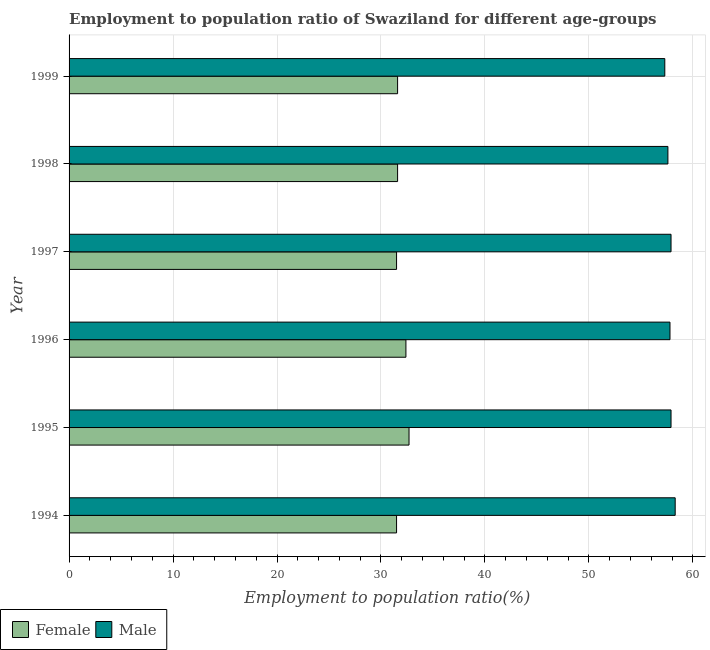How many different coloured bars are there?
Your answer should be very brief. 2. How many groups of bars are there?
Offer a very short reply. 6. How many bars are there on the 3rd tick from the bottom?
Ensure brevity in your answer.  2. What is the label of the 5th group of bars from the top?
Provide a succinct answer. 1995. In how many cases, is the number of bars for a given year not equal to the number of legend labels?
Provide a short and direct response. 0. What is the employment to population ratio(male) in 1994?
Your answer should be compact. 58.3. Across all years, what is the maximum employment to population ratio(male)?
Make the answer very short. 58.3. Across all years, what is the minimum employment to population ratio(female)?
Ensure brevity in your answer.  31.5. In which year was the employment to population ratio(male) maximum?
Offer a terse response. 1994. What is the total employment to population ratio(male) in the graph?
Offer a very short reply. 346.8. What is the difference between the employment to population ratio(male) in 1995 and the employment to population ratio(female) in 1999?
Offer a terse response. 26.3. What is the average employment to population ratio(female) per year?
Ensure brevity in your answer.  31.88. In the year 1997, what is the difference between the employment to population ratio(male) and employment to population ratio(female)?
Give a very brief answer. 26.4. What is the ratio of the employment to population ratio(male) in 1995 to that in 1997?
Keep it short and to the point. 1. What is the difference between the highest and the second highest employment to population ratio(male)?
Ensure brevity in your answer.  0.4. In how many years, is the employment to population ratio(female) greater than the average employment to population ratio(female) taken over all years?
Your answer should be very brief. 2. Is the sum of the employment to population ratio(female) in 1995 and 1996 greater than the maximum employment to population ratio(male) across all years?
Ensure brevity in your answer.  Yes. What does the 2nd bar from the top in 1996 represents?
Your response must be concise. Female. How many bars are there?
Provide a succinct answer. 12. How many years are there in the graph?
Make the answer very short. 6. Does the graph contain any zero values?
Provide a short and direct response. No. Does the graph contain grids?
Offer a terse response. Yes. Where does the legend appear in the graph?
Provide a succinct answer. Bottom left. What is the title of the graph?
Offer a very short reply. Employment to population ratio of Swaziland for different age-groups. Does "Male" appear as one of the legend labels in the graph?
Your answer should be compact. Yes. What is the label or title of the Y-axis?
Your answer should be compact. Year. What is the Employment to population ratio(%) of Female in 1994?
Offer a very short reply. 31.5. What is the Employment to population ratio(%) of Male in 1994?
Your response must be concise. 58.3. What is the Employment to population ratio(%) in Female in 1995?
Ensure brevity in your answer.  32.7. What is the Employment to population ratio(%) in Male in 1995?
Make the answer very short. 57.9. What is the Employment to population ratio(%) in Female in 1996?
Your answer should be compact. 32.4. What is the Employment to population ratio(%) of Male in 1996?
Provide a short and direct response. 57.8. What is the Employment to population ratio(%) of Female in 1997?
Give a very brief answer. 31.5. What is the Employment to population ratio(%) of Male in 1997?
Your answer should be compact. 57.9. What is the Employment to population ratio(%) of Female in 1998?
Provide a short and direct response. 31.6. What is the Employment to population ratio(%) in Male in 1998?
Provide a succinct answer. 57.6. What is the Employment to population ratio(%) in Female in 1999?
Provide a short and direct response. 31.6. What is the Employment to population ratio(%) in Male in 1999?
Your answer should be compact. 57.3. Across all years, what is the maximum Employment to population ratio(%) of Female?
Your response must be concise. 32.7. Across all years, what is the maximum Employment to population ratio(%) in Male?
Your answer should be compact. 58.3. Across all years, what is the minimum Employment to population ratio(%) of Female?
Offer a terse response. 31.5. Across all years, what is the minimum Employment to population ratio(%) in Male?
Offer a very short reply. 57.3. What is the total Employment to population ratio(%) of Female in the graph?
Ensure brevity in your answer.  191.3. What is the total Employment to population ratio(%) of Male in the graph?
Provide a short and direct response. 346.8. What is the difference between the Employment to population ratio(%) in Male in 1994 and that in 1995?
Provide a short and direct response. 0.4. What is the difference between the Employment to population ratio(%) of Female in 1994 and that in 1997?
Make the answer very short. 0. What is the difference between the Employment to population ratio(%) in Male in 1994 and that in 1997?
Your answer should be very brief. 0.4. What is the difference between the Employment to population ratio(%) in Female in 1994 and that in 1998?
Provide a short and direct response. -0.1. What is the difference between the Employment to population ratio(%) in Male in 1994 and that in 1998?
Provide a succinct answer. 0.7. What is the difference between the Employment to population ratio(%) in Male in 1994 and that in 1999?
Ensure brevity in your answer.  1. What is the difference between the Employment to population ratio(%) of Female in 1995 and that in 1996?
Give a very brief answer. 0.3. What is the difference between the Employment to population ratio(%) in Female in 1995 and that in 1998?
Provide a succinct answer. 1.1. What is the difference between the Employment to population ratio(%) in Female in 1995 and that in 1999?
Offer a very short reply. 1.1. What is the difference between the Employment to population ratio(%) in Male in 1995 and that in 1999?
Keep it short and to the point. 0.6. What is the difference between the Employment to population ratio(%) in Female in 1996 and that in 1998?
Keep it short and to the point. 0.8. What is the difference between the Employment to population ratio(%) in Female in 1997 and that in 1998?
Offer a very short reply. -0.1. What is the difference between the Employment to population ratio(%) in Male in 1997 and that in 1998?
Make the answer very short. 0.3. What is the difference between the Employment to population ratio(%) in Female in 1997 and that in 1999?
Ensure brevity in your answer.  -0.1. What is the difference between the Employment to population ratio(%) of Male in 1998 and that in 1999?
Give a very brief answer. 0.3. What is the difference between the Employment to population ratio(%) of Female in 1994 and the Employment to population ratio(%) of Male in 1995?
Keep it short and to the point. -26.4. What is the difference between the Employment to population ratio(%) in Female in 1994 and the Employment to population ratio(%) in Male in 1996?
Offer a very short reply. -26.3. What is the difference between the Employment to population ratio(%) of Female in 1994 and the Employment to population ratio(%) of Male in 1997?
Keep it short and to the point. -26.4. What is the difference between the Employment to population ratio(%) of Female in 1994 and the Employment to population ratio(%) of Male in 1998?
Provide a short and direct response. -26.1. What is the difference between the Employment to population ratio(%) in Female in 1994 and the Employment to population ratio(%) in Male in 1999?
Your answer should be very brief. -25.8. What is the difference between the Employment to population ratio(%) in Female in 1995 and the Employment to population ratio(%) in Male in 1996?
Offer a very short reply. -25.1. What is the difference between the Employment to population ratio(%) in Female in 1995 and the Employment to population ratio(%) in Male in 1997?
Provide a succinct answer. -25.2. What is the difference between the Employment to population ratio(%) in Female in 1995 and the Employment to population ratio(%) in Male in 1998?
Give a very brief answer. -24.9. What is the difference between the Employment to population ratio(%) of Female in 1995 and the Employment to population ratio(%) of Male in 1999?
Make the answer very short. -24.6. What is the difference between the Employment to population ratio(%) of Female in 1996 and the Employment to population ratio(%) of Male in 1997?
Your response must be concise. -25.5. What is the difference between the Employment to population ratio(%) in Female in 1996 and the Employment to population ratio(%) in Male in 1998?
Your answer should be compact. -25.2. What is the difference between the Employment to population ratio(%) of Female in 1996 and the Employment to population ratio(%) of Male in 1999?
Make the answer very short. -24.9. What is the difference between the Employment to population ratio(%) of Female in 1997 and the Employment to population ratio(%) of Male in 1998?
Offer a very short reply. -26.1. What is the difference between the Employment to population ratio(%) of Female in 1997 and the Employment to population ratio(%) of Male in 1999?
Provide a short and direct response. -25.8. What is the difference between the Employment to population ratio(%) of Female in 1998 and the Employment to population ratio(%) of Male in 1999?
Your answer should be compact. -25.7. What is the average Employment to population ratio(%) of Female per year?
Offer a very short reply. 31.88. What is the average Employment to population ratio(%) in Male per year?
Give a very brief answer. 57.8. In the year 1994, what is the difference between the Employment to population ratio(%) in Female and Employment to population ratio(%) in Male?
Offer a very short reply. -26.8. In the year 1995, what is the difference between the Employment to population ratio(%) of Female and Employment to population ratio(%) of Male?
Offer a very short reply. -25.2. In the year 1996, what is the difference between the Employment to population ratio(%) in Female and Employment to population ratio(%) in Male?
Make the answer very short. -25.4. In the year 1997, what is the difference between the Employment to population ratio(%) of Female and Employment to population ratio(%) of Male?
Make the answer very short. -26.4. In the year 1998, what is the difference between the Employment to population ratio(%) in Female and Employment to population ratio(%) in Male?
Your response must be concise. -26. In the year 1999, what is the difference between the Employment to population ratio(%) in Female and Employment to population ratio(%) in Male?
Make the answer very short. -25.7. What is the ratio of the Employment to population ratio(%) of Female in 1994 to that in 1995?
Provide a short and direct response. 0.96. What is the ratio of the Employment to population ratio(%) in Female in 1994 to that in 1996?
Offer a terse response. 0.97. What is the ratio of the Employment to population ratio(%) of Male in 1994 to that in 1996?
Your response must be concise. 1.01. What is the ratio of the Employment to population ratio(%) in Male in 1994 to that in 1997?
Give a very brief answer. 1.01. What is the ratio of the Employment to population ratio(%) in Female in 1994 to that in 1998?
Your response must be concise. 1. What is the ratio of the Employment to population ratio(%) of Male in 1994 to that in 1998?
Offer a very short reply. 1.01. What is the ratio of the Employment to population ratio(%) in Female in 1994 to that in 1999?
Ensure brevity in your answer.  1. What is the ratio of the Employment to population ratio(%) in Male in 1994 to that in 1999?
Keep it short and to the point. 1.02. What is the ratio of the Employment to population ratio(%) in Female in 1995 to that in 1996?
Provide a succinct answer. 1.01. What is the ratio of the Employment to population ratio(%) in Male in 1995 to that in 1996?
Your answer should be compact. 1. What is the ratio of the Employment to population ratio(%) of Female in 1995 to that in 1997?
Provide a short and direct response. 1.04. What is the ratio of the Employment to population ratio(%) in Male in 1995 to that in 1997?
Ensure brevity in your answer.  1. What is the ratio of the Employment to population ratio(%) of Female in 1995 to that in 1998?
Your answer should be very brief. 1.03. What is the ratio of the Employment to population ratio(%) of Female in 1995 to that in 1999?
Keep it short and to the point. 1.03. What is the ratio of the Employment to population ratio(%) in Male in 1995 to that in 1999?
Give a very brief answer. 1.01. What is the ratio of the Employment to population ratio(%) in Female in 1996 to that in 1997?
Keep it short and to the point. 1.03. What is the ratio of the Employment to population ratio(%) in Female in 1996 to that in 1998?
Your answer should be very brief. 1.03. What is the ratio of the Employment to population ratio(%) in Female in 1996 to that in 1999?
Your answer should be compact. 1.03. What is the ratio of the Employment to population ratio(%) in Male in 1996 to that in 1999?
Offer a very short reply. 1.01. What is the ratio of the Employment to population ratio(%) in Female in 1997 to that in 1998?
Keep it short and to the point. 1. What is the ratio of the Employment to population ratio(%) of Male in 1997 to that in 1998?
Provide a short and direct response. 1.01. What is the ratio of the Employment to population ratio(%) of Female in 1997 to that in 1999?
Your answer should be very brief. 1. What is the ratio of the Employment to population ratio(%) in Male in 1997 to that in 1999?
Offer a very short reply. 1.01. What is the difference between the highest and the lowest Employment to population ratio(%) in Female?
Your answer should be compact. 1.2. 